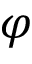Convert formula to latex. <formula><loc_0><loc_0><loc_500><loc_500>\varphi</formula> 